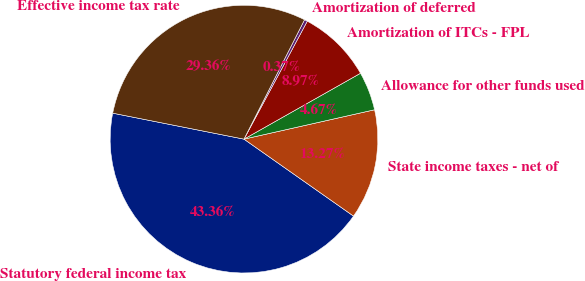Convert chart. <chart><loc_0><loc_0><loc_500><loc_500><pie_chart><fcel>Statutory federal income tax<fcel>State income taxes - net of<fcel>Allowance for other funds used<fcel>Amortization of ITCs - FPL<fcel>Amortization of deferred<fcel>Effective income tax rate<nl><fcel>43.36%<fcel>13.27%<fcel>4.67%<fcel>8.97%<fcel>0.37%<fcel>29.36%<nl></chart> 